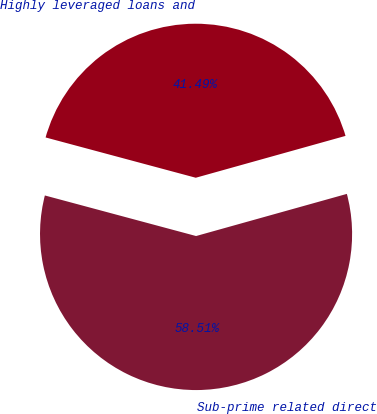<chart> <loc_0><loc_0><loc_500><loc_500><pie_chart><fcel>Sub-prime related direct<fcel>Highly leveraged loans and<nl><fcel>58.51%<fcel>41.49%<nl></chart> 